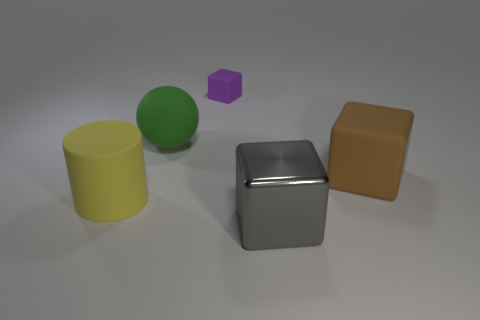Add 4 rubber cylinders. How many objects exist? 9 Subtract all spheres. How many objects are left? 4 Add 3 large spheres. How many large spheres are left? 4 Add 4 large yellow rubber cylinders. How many large yellow rubber cylinders exist? 5 Subtract 0 cyan cylinders. How many objects are left? 5 Subtract all small matte objects. Subtract all purple matte cubes. How many objects are left? 3 